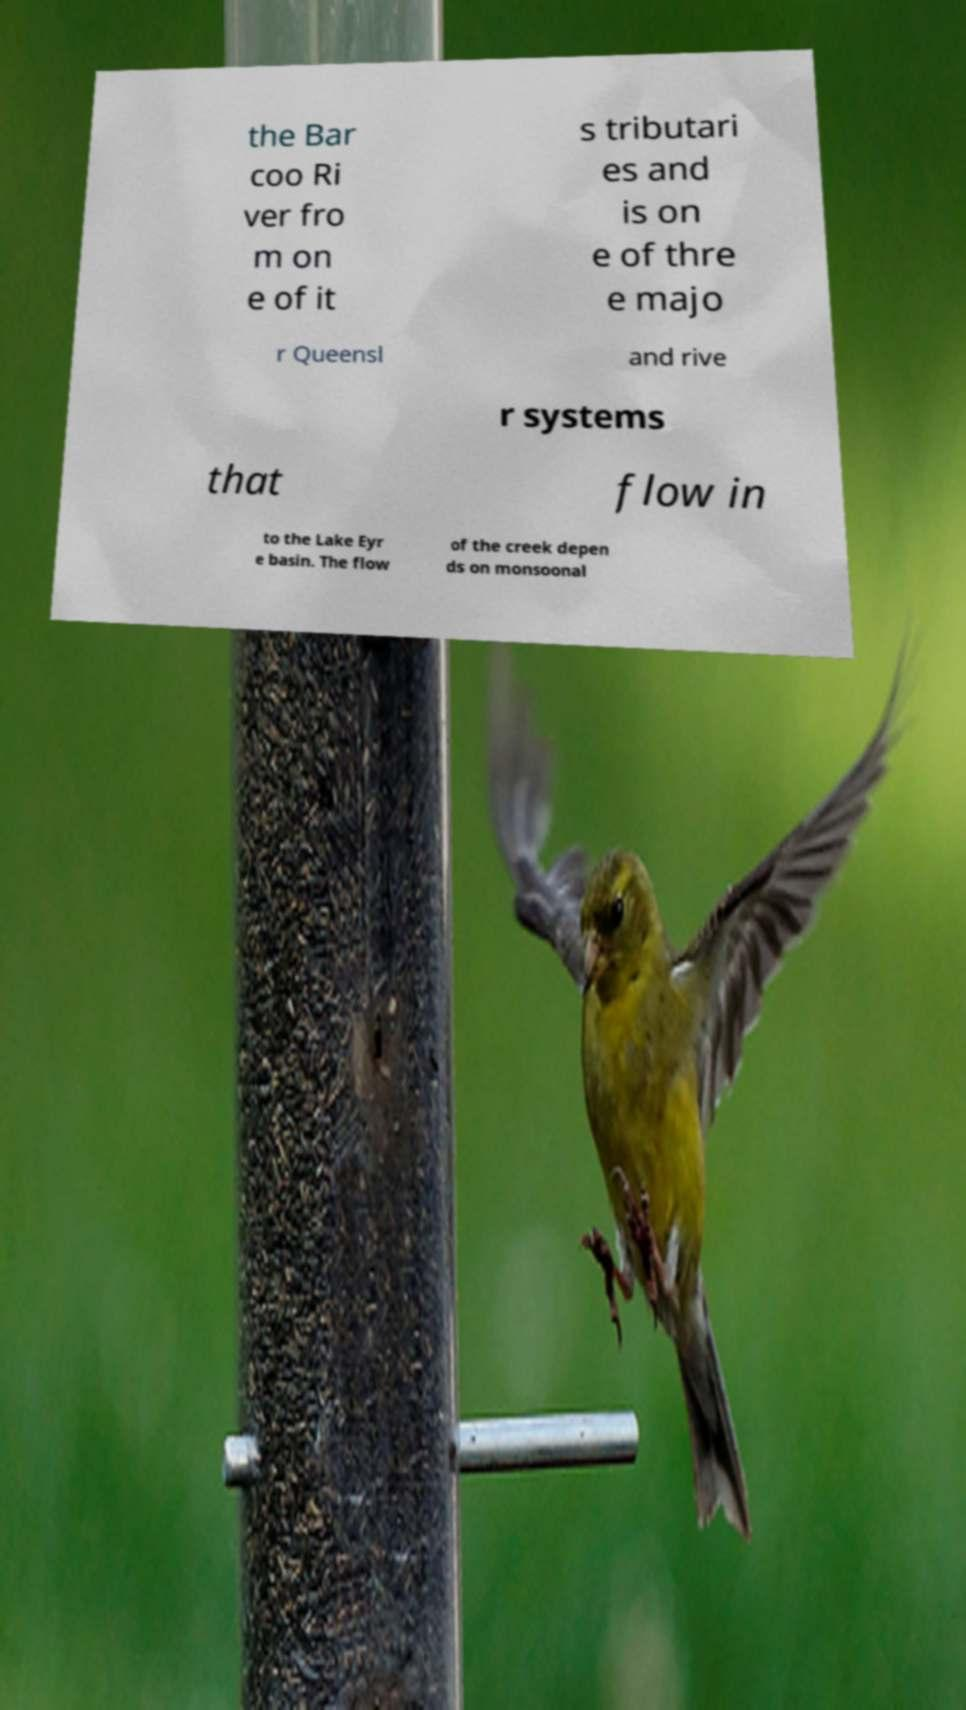For documentation purposes, I need the text within this image transcribed. Could you provide that? the Bar coo Ri ver fro m on e of it s tributari es and is on e of thre e majo r Queensl and rive r systems that flow in to the Lake Eyr e basin. The flow of the creek depen ds on monsoonal 